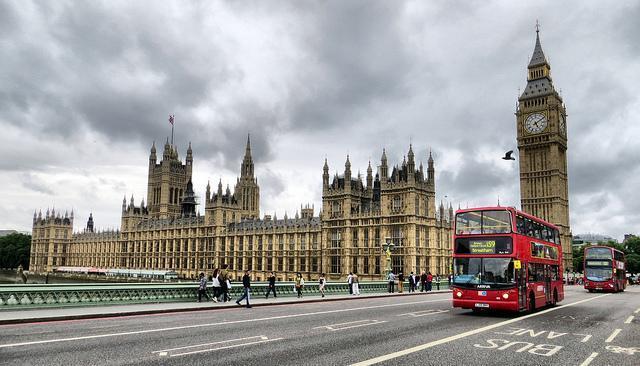How many buses can you see?
Give a very brief answer. 1. How many train cars is shown?
Give a very brief answer. 0. 